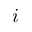<formula> <loc_0><loc_0><loc_500><loc_500>i</formula> 